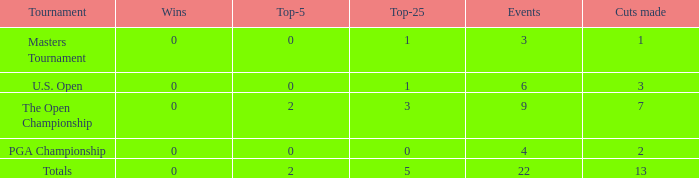What is the fewest wins for Thomas in events he had entered exactly 9 times? 0.0. 